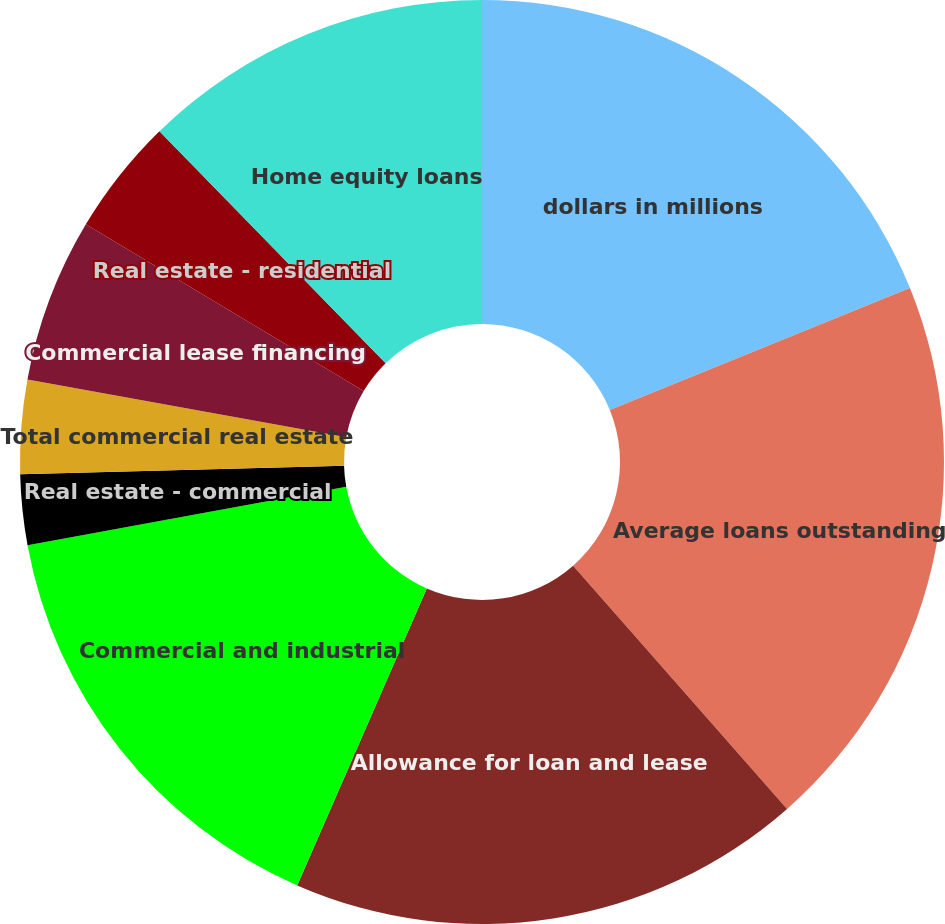Convert chart to OTSL. <chart><loc_0><loc_0><loc_500><loc_500><pie_chart><fcel>dollars in millions<fcel>Average loans outstanding<fcel>Allowance for loan and lease<fcel>Commercial and industrial<fcel>Real estate - commercial<fcel>Real estate - construction<fcel>Total commercial real estate<fcel>Commercial lease financing<fcel>Real estate - residential<fcel>Home equity loans<nl><fcel>18.85%<fcel>19.67%<fcel>18.03%<fcel>15.57%<fcel>2.46%<fcel>0.0%<fcel>3.28%<fcel>5.74%<fcel>4.1%<fcel>12.3%<nl></chart> 